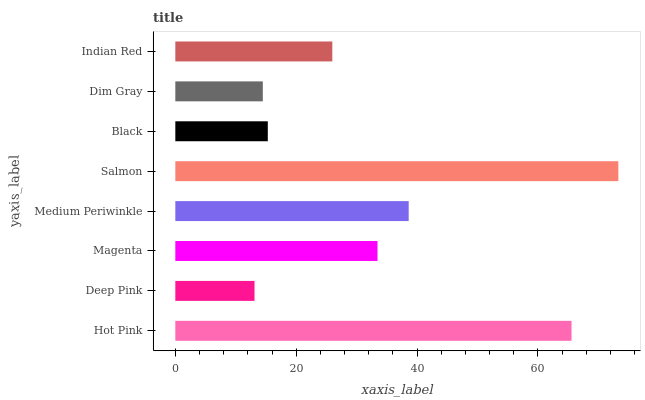Is Deep Pink the minimum?
Answer yes or no. Yes. Is Salmon the maximum?
Answer yes or no. Yes. Is Magenta the minimum?
Answer yes or no. No. Is Magenta the maximum?
Answer yes or no. No. Is Magenta greater than Deep Pink?
Answer yes or no. Yes. Is Deep Pink less than Magenta?
Answer yes or no. Yes. Is Deep Pink greater than Magenta?
Answer yes or no. No. Is Magenta less than Deep Pink?
Answer yes or no. No. Is Magenta the high median?
Answer yes or no. Yes. Is Indian Red the low median?
Answer yes or no. Yes. Is Deep Pink the high median?
Answer yes or no. No. Is Deep Pink the low median?
Answer yes or no. No. 